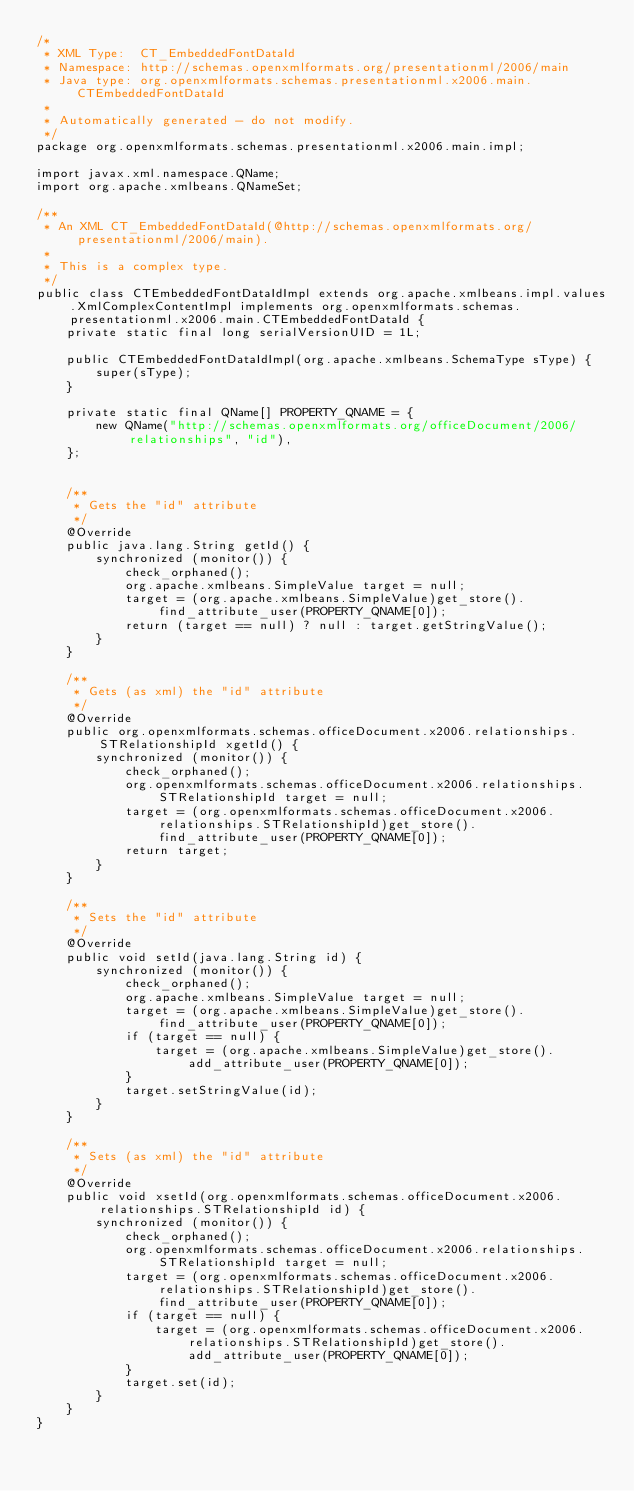Convert code to text. <code><loc_0><loc_0><loc_500><loc_500><_Java_>/*
 * XML Type:  CT_EmbeddedFontDataId
 * Namespace: http://schemas.openxmlformats.org/presentationml/2006/main
 * Java type: org.openxmlformats.schemas.presentationml.x2006.main.CTEmbeddedFontDataId
 *
 * Automatically generated - do not modify.
 */
package org.openxmlformats.schemas.presentationml.x2006.main.impl;

import javax.xml.namespace.QName;
import org.apache.xmlbeans.QNameSet;

/**
 * An XML CT_EmbeddedFontDataId(@http://schemas.openxmlformats.org/presentationml/2006/main).
 *
 * This is a complex type.
 */
public class CTEmbeddedFontDataIdImpl extends org.apache.xmlbeans.impl.values.XmlComplexContentImpl implements org.openxmlformats.schemas.presentationml.x2006.main.CTEmbeddedFontDataId {
    private static final long serialVersionUID = 1L;

    public CTEmbeddedFontDataIdImpl(org.apache.xmlbeans.SchemaType sType) {
        super(sType);
    }

    private static final QName[] PROPERTY_QNAME = {
        new QName("http://schemas.openxmlformats.org/officeDocument/2006/relationships", "id"),
    };


    /**
     * Gets the "id" attribute
     */
    @Override
    public java.lang.String getId() {
        synchronized (monitor()) {
            check_orphaned();
            org.apache.xmlbeans.SimpleValue target = null;
            target = (org.apache.xmlbeans.SimpleValue)get_store().find_attribute_user(PROPERTY_QNAME[0]);
            return (target == null) ? null : target.getStringValue();
        }
    }

    /**
     * Gets (as xml) the "id" attribute
     */
    @Override
    public org.openxmlformats.schemas.officeDocument.x2006.relationships.STRelationshipId xgetId() {
        synchronized (monitor()) {
            check_orphaned();
            org.openxmlformats.schemas.officeDocument.x2006.relationships.STRelationshipId target = null;
            target = (org.openxmlformats.schemas.officeDocument.x2006.relationships.STRelationshipId)get_store().find_attribute_user(PROPERTY_QNAME[0]);
            return target;
        }
    }

    /**
     * Sets the "id" attribute
     */
    @Override
    public void setId(java.lang.String id) {
        synchronized (monitor()) {
            check_orphaned();
            org.apache.xmlbeans.SimpleValue target = null;
            target = (org.apache.xmlbeans.SimpleValue)get_store().find_attribute_user(PROPERTY_QNAME[0]);
            if (target == null) {
                target = (org.apache.xmlbeans.SimpleValue)get_store().add_attribute_user(PROPERTY_QNAME[0]);
            }
            target.setStringValue(id);
        }
    }

    /**
     * Sets (as xml) the "id" attribute
     */
    @Override
    public void xsetId(org.openxmlformats.schemas.officeDocument.x2006.relationships.STRelationshipId id) {
        synchronized (monitor()) {
            check_orphaned();
            org.openxmlformats.schemas.officeDocument.x2006.relationships.STRelationshipId target = null;
            target = (org.openxmlformats.schemas.officeDocument.x2006.relationships.STRelationshipId)get_store().find_attribute_user(PROPERTY_QNAME[0]);
            if (target == null) {
                target = (org.openxmlformats.schemas.officeDocument.x2006.relationships.STRelationshipId)get_store().add_attribute_user(PROPERTY_QNAME[0]);
            }
            target.set(id);
        }
    }
}
</code> 